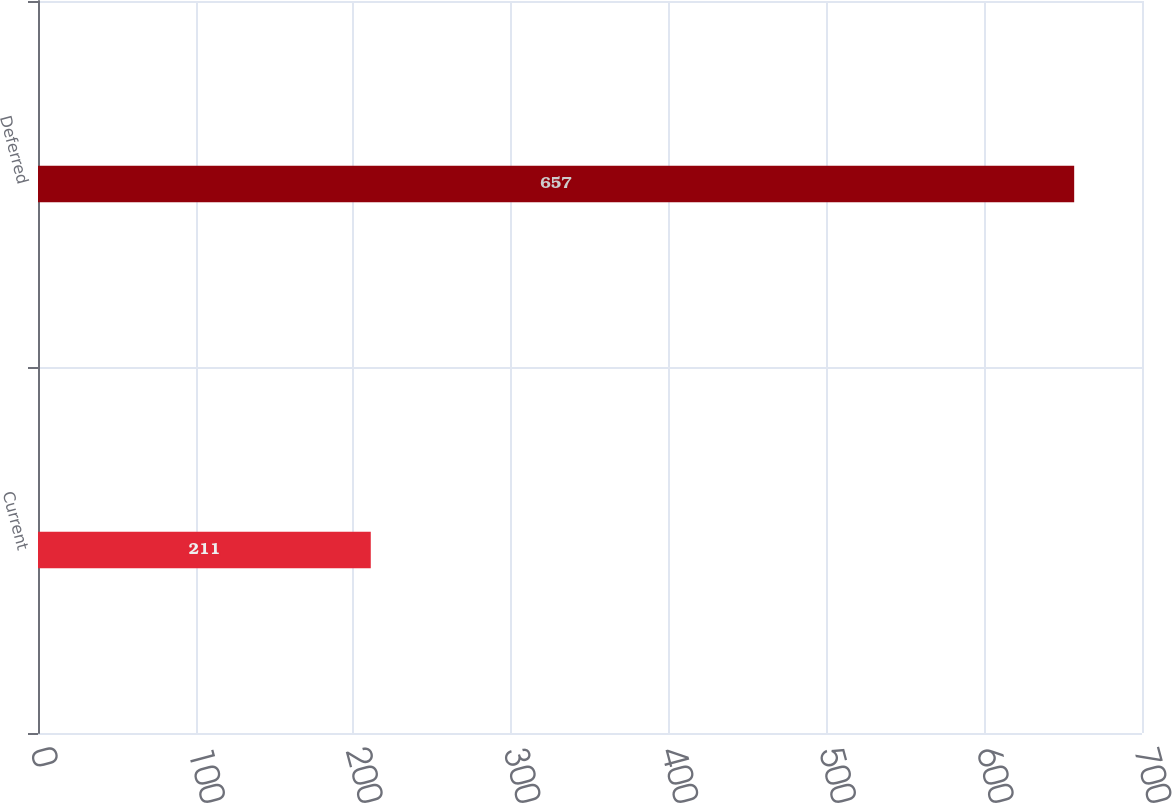Convert chart to OTSL. <chart><loc_0><loc_0><loc_500><loc_500><bar_chart><fcel>Current<fcel>Deferred<nl><fcel>211<fcel>657<nl></chart> 